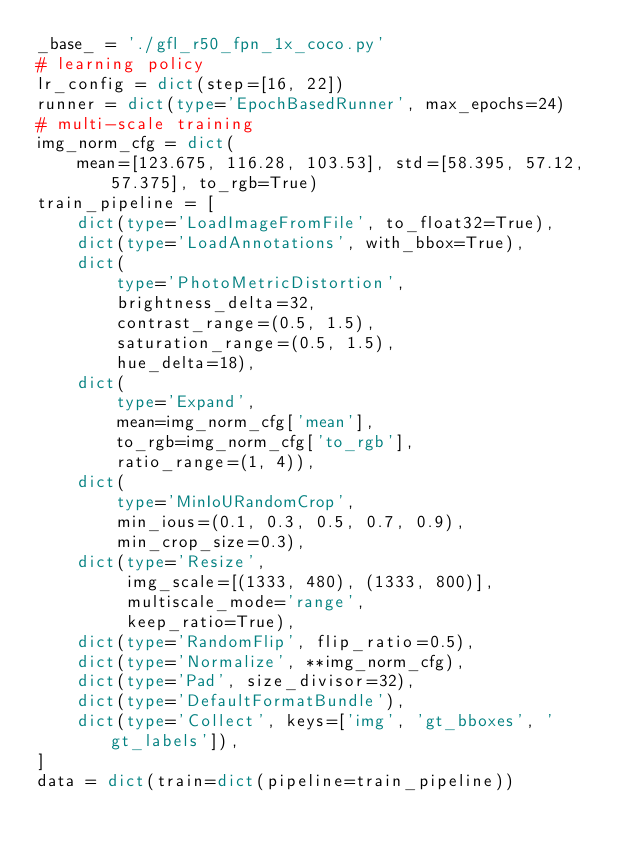<code> <loc_0><loc_0><loc_500><loc_500><_Python_>_base_ = './gfl_r50_fpn_1x_coco.py'
# learning policy
lr_config = dict(step=[16, 22])
runner = dict(type='EpochBasedRunner', max_epochs=24)
# multi-scale training
img_norm_cfg = dict(
    mean=[123.675, 116.28, 103.53], std=[58.395, 57.12, 57.375], to_rgb=True)
train_pipeline = [
    dict(type='LoadImageFromFile', to_float32=True),
    dict(type='LoadAnnotations', with_bbox=True),
    dict(
        type='PhotoMetricDistortion',
        brightness_delta=32,
        contrast_range=(0.5, 1.5),
        saturation_range=(0.5, 1.5),
        hue_delta=18),
    dict(
        type='Expand',
        mean=img_norm_cfg['mean'],
        to_rgb=img_norm_cfg['to_rgb'],
        ratio_range=(1, 4)),
    dict(
        type='MinIoURandomCrop',
        min_ious=(0.1, 0.3, 0.5, 0.7, 0.9),
        min_crop_size=0.3),
    dict(type='Resize',
         img_scale=[(1333, 480), (1333, 800)],
         multiscale_mode='range',
         keep_ratio=True),
    dict(type='RandomFlip', flip_ratio=0.5),
    dict(type='Normalize', **img_norm_cfg),
    dict(type='Pad', size_divisor=32),
    dict(type='DefaultFormatBundle'),
    dict(type='Collect', keys=['img', 'gt_bboxes', 'gt_labels']),
]
data = dict(train=dict(pipeline=train_pipeline))
</code> 